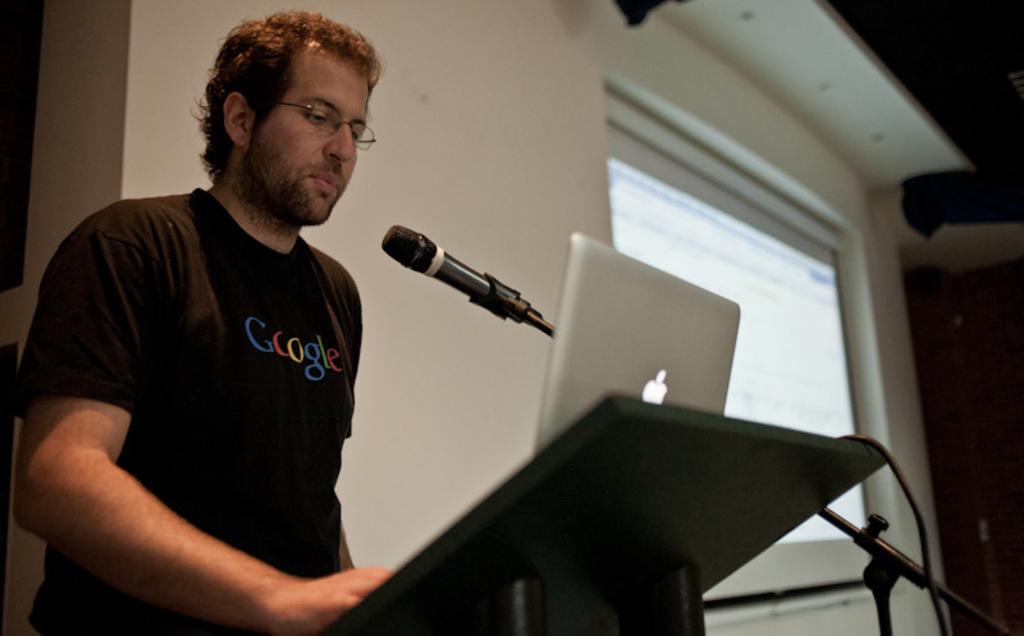Could you give a brief overview of what you see in this image? In this image there is a person standing on the stage near the podium, on the podium there is a laptop, a microphone to the stand and there is a screen. 